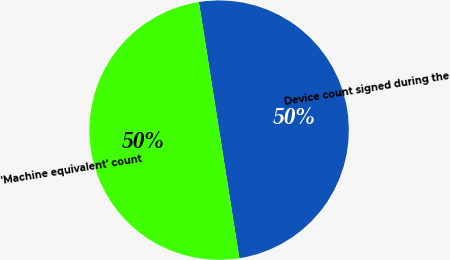Convert chart. <chart><loc_0><loc_0><loc_500><loc_500><pie_chart><fcel>Device count signed during the<fcel>'Machine equivalent' count<nl><fcel>50.0%<fcel>50.0%<nl></chart> 